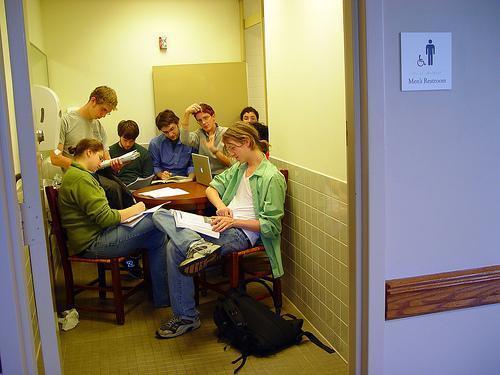How many faces are there?
Give a very brief answer. 7. How many computers are there?
Give a very brief answer. 1. 